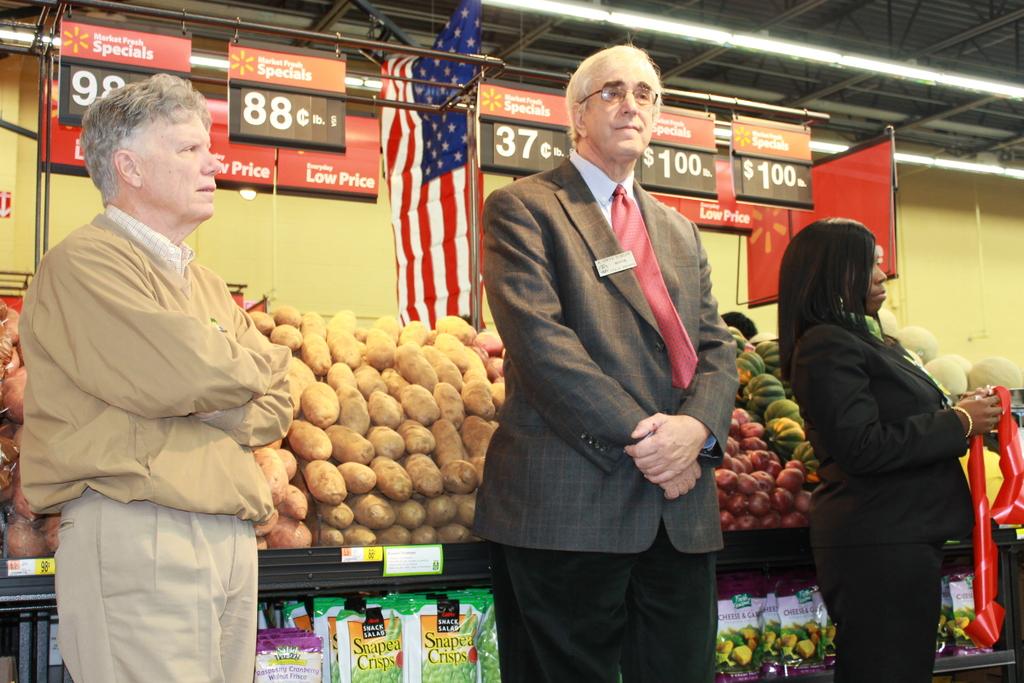How much is the produce on the far right?
Provide a succinct answer. $1. How much is the produce on the left?
Offer a very short reply. 98 cents. 